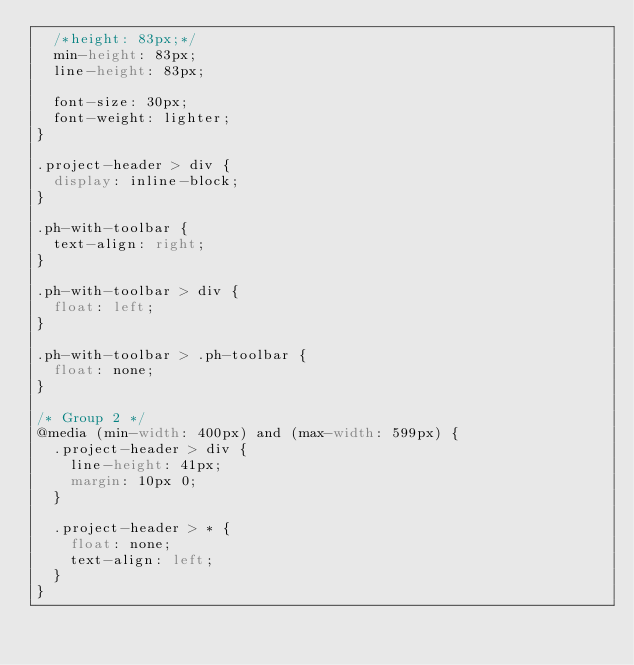Convert code to text. <code><loc_0><loc_0><loc_500><loc_500><_CSS_>  /*height: 83px;*/
  min-height: 83px;
  line-height: 83px;

  font-size: 30px;
  font-weight: lighter;
}

.project-header > div {
  display: inline-block;
}

.ph-with-toolbar {
  text-align: right;
}

.ph-with-toolbar > div {
  float: left;
}

.ph-with-toolbar > .ph-toolbar {
  float: none;
}

/* Group 2 */
@media (min-width: 400px) and (max-width: 599px) {
  .project-header > div {
    line-height: 41px;
    margin: 10px 0;
  }

  .project-header > * {
    float: none;
    text-align: left;
  }
}</code> 